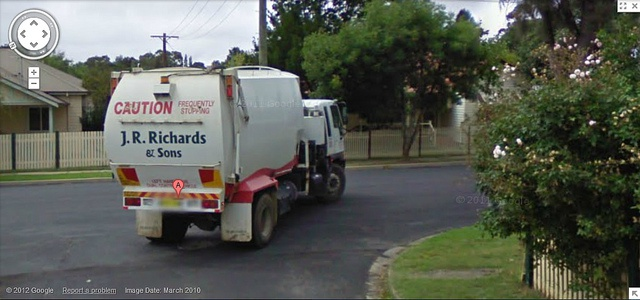Describe the objects in this image and their specific colors. I can see a truck in darkgray, gray, black, and lightgray tones in this image. 